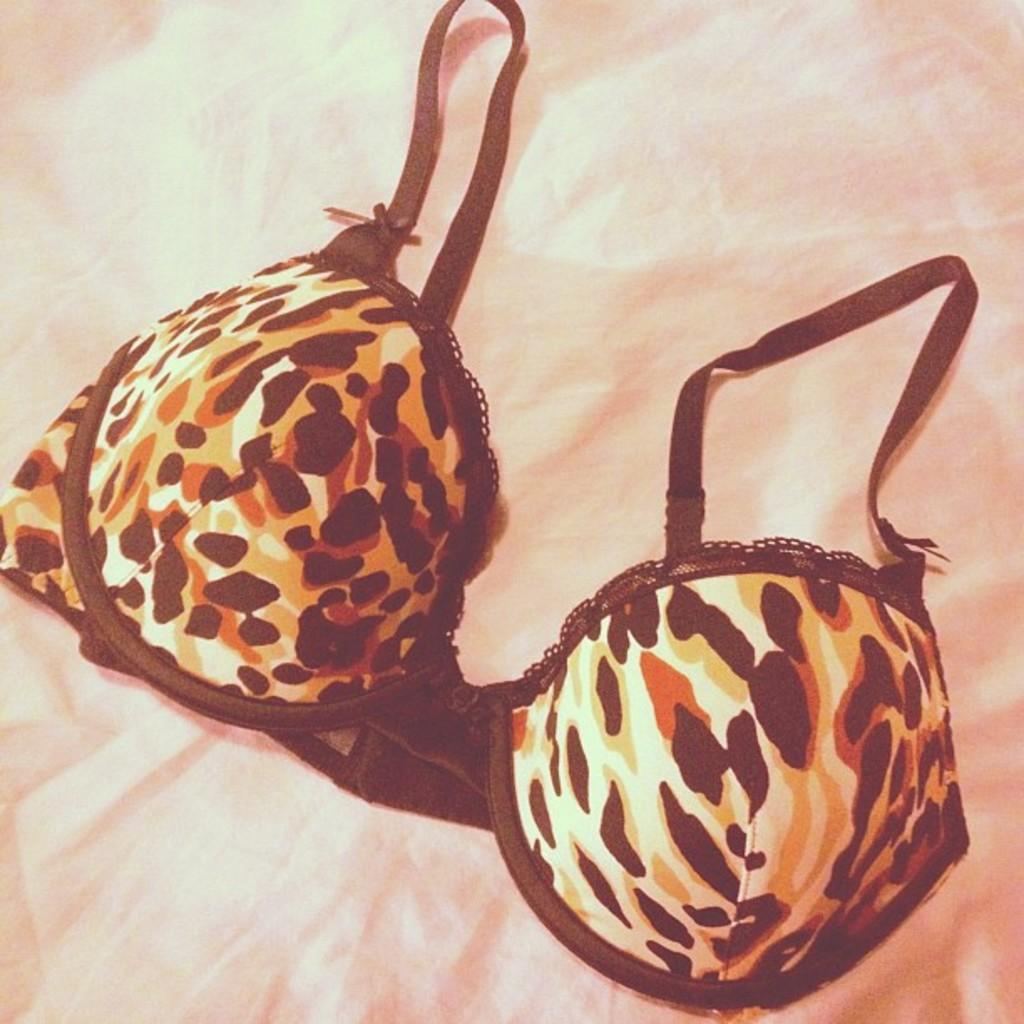What type of clothing item is visible in the image? There is a lingerie top in the image. Where is the lingerie top located? The lingerie top is placed on a surface. What type of smile can be seen on the lingerie top in the image? There is no smile present on the lingerie top in the image, as it is an inanimate object. 